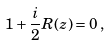Convert formula to latex. <formula><loc_0><loc_0><loc_500><loc_500>1 + \frac { i } { 2 } R ( z ) = 0 \, ,</formula> 